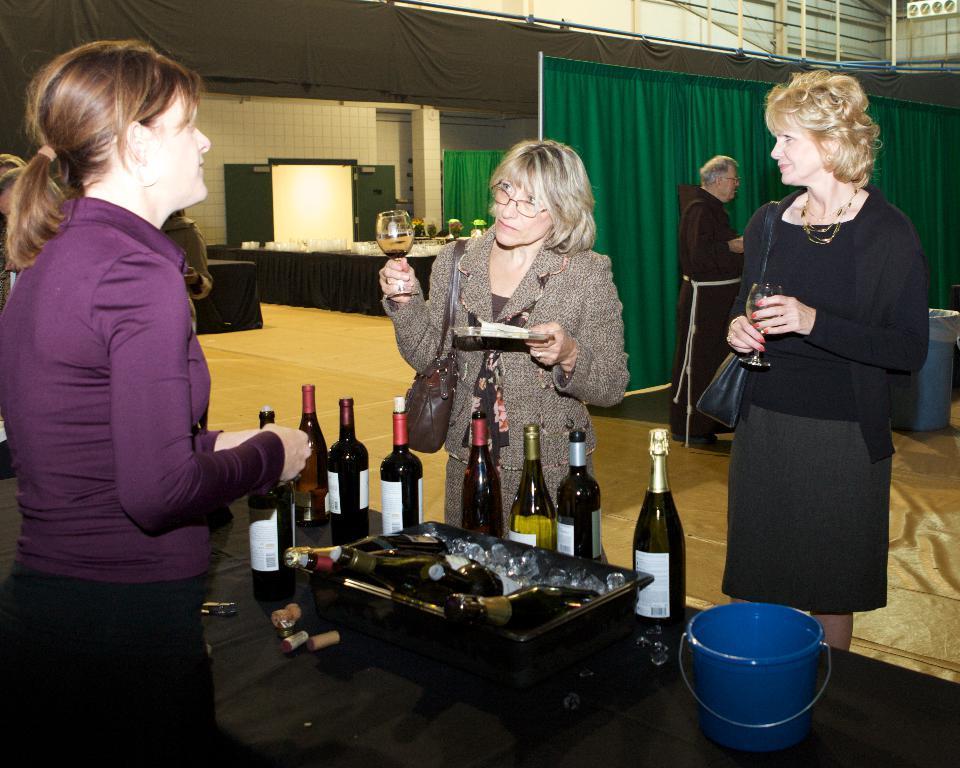Describe this image in one or two sentences. In this image there are three woman who are standing and they are holding glasses, and on the background there is one man who is standing and in the bottom there is one table and on that table there are some glasses and some ice cubes and one basket is there and also one bucket is there on the table. And on the top there is a wall and one black color curtain is there and on the right side there is one green color curtain and on the left side there is wall and some door is there and some tables are there. 